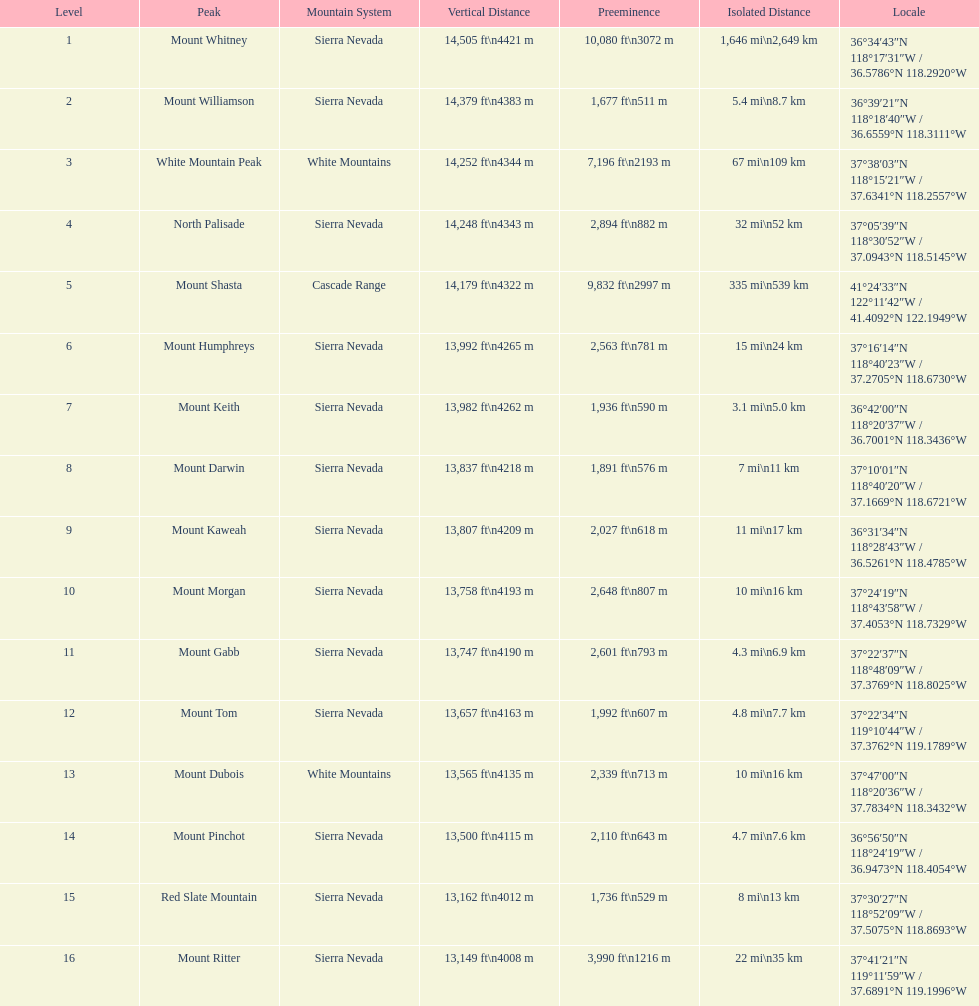Which is taller, mount humphreys or mount kaweah. Mount Humphreys. 